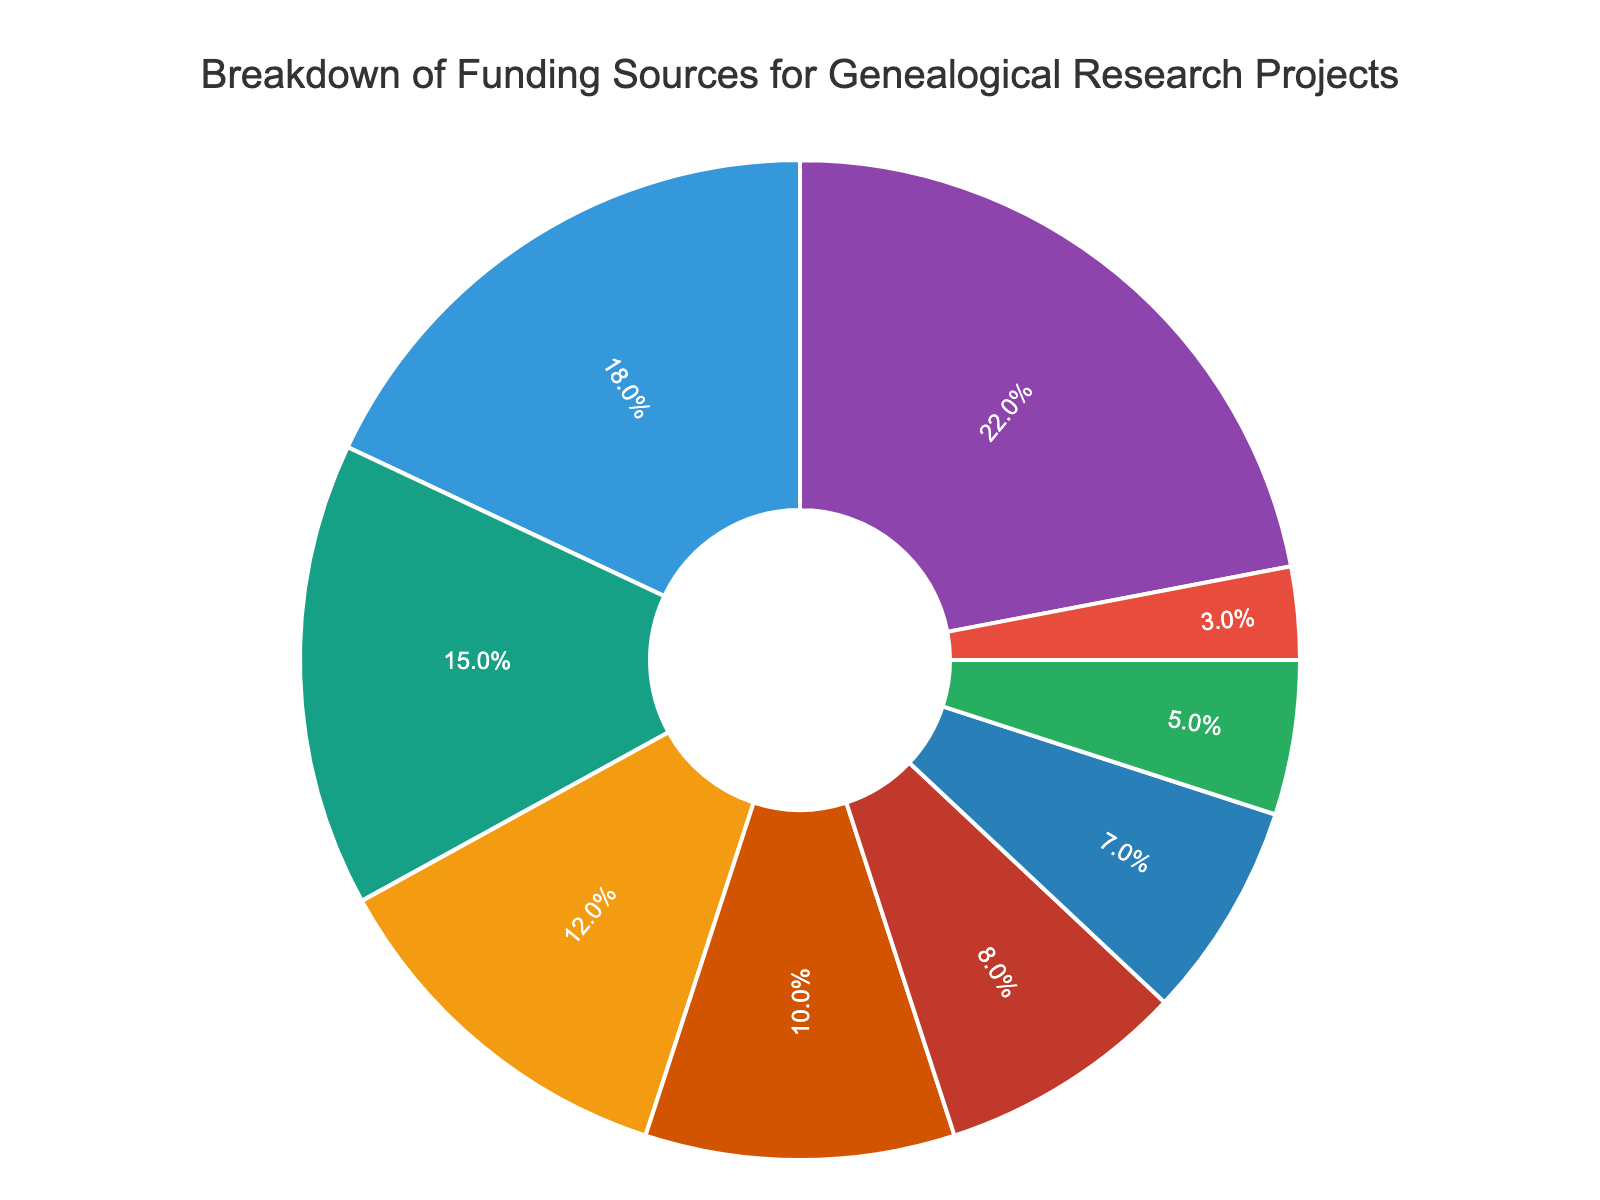What funding source contributes the highest percentage to genealogical research projects? The pie chart indicates that the segment representing "National Genealogical Society Grants" is the largest portion of the chart.
Answer: National Genealogical Society Grants Which funding sources contribute less than 10% each? The pie chart shows segments of various sizes, but only those corresponding to "Crowdfunding Platforms," "Private Donor Contributions," "State Archives Funding," and "Genealogical DNA Testing Companies" are smaller and represent 8%, 7%, 5%, and 3%, respectively.
Answer: Crowdfunding Platforms, Private Donor Contributions, State Archives Funding, Genealogical DNA Testing Companies What's the combined percentage of Museums and Historical Societies funding and University Research Grants? Sum the percentages for "Museums and Historical Societies funding" (12%) and "University Research Grants" (10%). The combined total is 12% + 10% = 22%.
Answer: 22% How does the contribution from Family History Library Funding compare to that from Ancestry.com Research Sponsorships? The pie chart shows that "Family History Library Funding" accounts for 18% and "Ancestry.com Research Sponsorships" accounts for 15%. Thus, Family History Library Funding has a higher contribution than Ancestry.com Research Sponsorships.
Answer: Family History Library Funding contributes more What's the difference in the percentage contributions between the largest and smallest funding sources? The largest funding source is "National Genealogical Society Grants" at 22%, and the smallest is "Genealogical DNA Testing Companies" at 3%. The difference is calculated as 22% - 3% = 19%.
Answer: 19% Which funding source is represented by the green segment? Observing the pie chart, the green segment represents "Family History Library Funding" at 18%.
Answer: Family History Library Funding Is the proportion of State Archives Funding higher or lower than that of Private Donor Contributions? According to the pie chart, "State Archives Funding" is 5% and "Private Donor Contributions" is 7%. Therefore, the proportion of State Archives Funding is lower.
Answer: Lower Calculate the average percentage of the four largest contributors to genealogical research funding. The four largest contributors are "National Genealogical Society Grants" (22%), "Family History Library Funding" (18%), "Ancestry.com Research Sponsorships" (15%), and "Museums and Historical Societies" (12%). The average is calculated as (22% + 18% + 15% + 12%) / 4 = 67% / 4 = 16.75%.
Answer: 16.75% What is the combined contribution of all sources that fund less than 10% each? "Crowdfunding Platforms" (8%), "Private Donor Contributions" (7%), "State Archives Funding" (5%), and "Genealogical DNA Testing Companies" (3%) each contribute less than 10%. The combined contribution is 8% + 7% + 5% + 3% = 23%.
Answer: 23% Which two sources have the closest percentage contributions, and what are those percentages? By examining the pie chart percentages, "Crowdfunding Platforms" (8%) and "Private Donor Contributions" (7%) have the closest percentages compared to the others.
Answer: Crowdfunding Platforms and Private Donor Contributions at 8% and 7%, respectively 